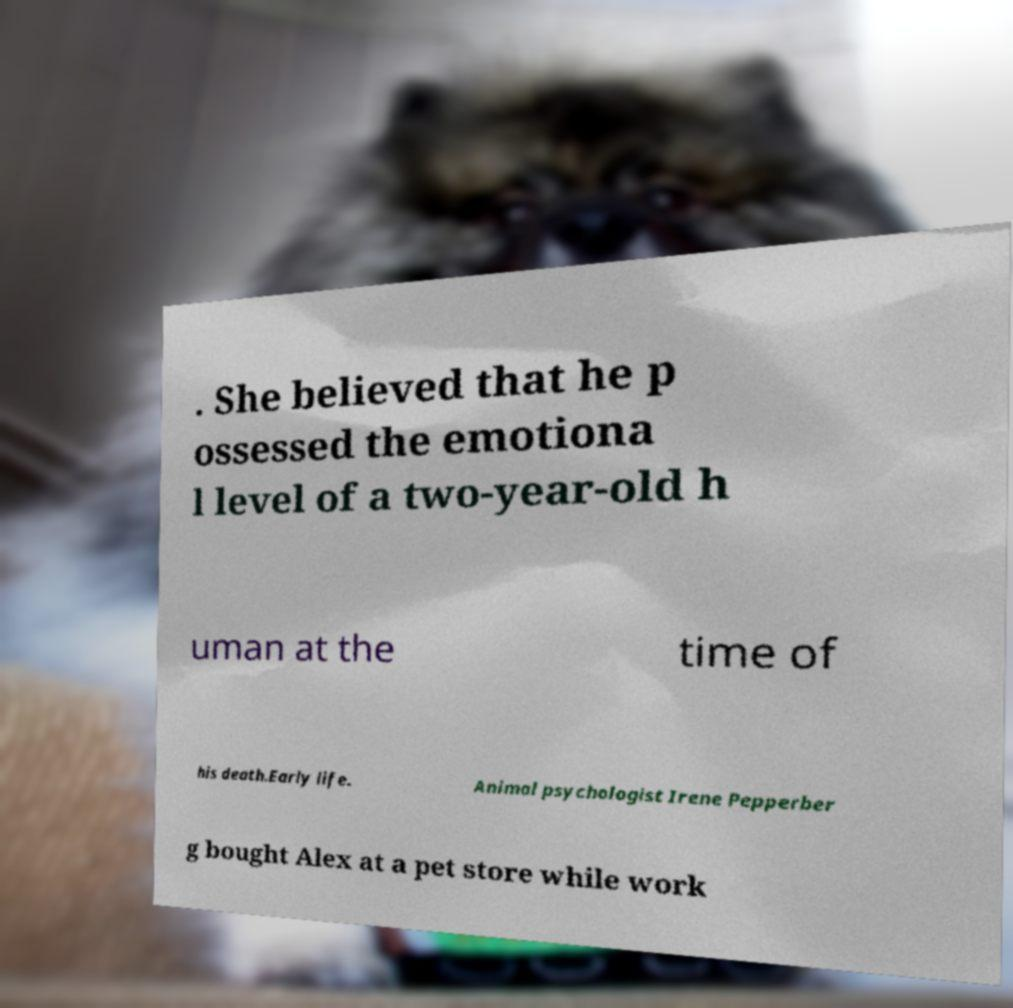Could you extract and type out the text from this image? . She believed that he p ossessed the emotiona l level of a two-year-old h uman at the time of his death.Early life. Animal psychologist Irene Pepperber g bought Alex at a pet store while work 